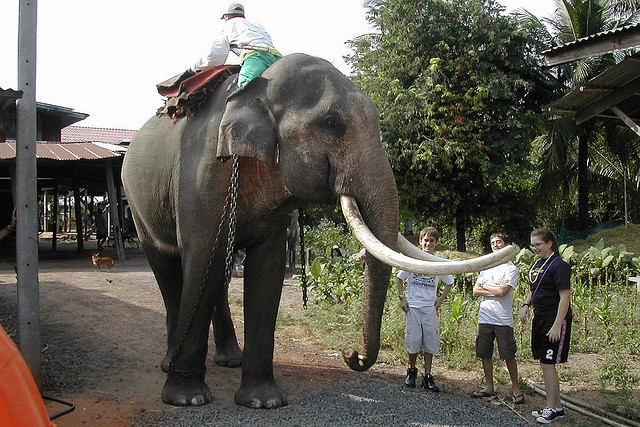Describe the objects in this image and their specific colors. I can see elephant in white, black, gray, and darkgray tones, people in white, black, gray, and darkgray tones, people in white, black, darkgray, and gray tones, people in white, darkgray, gray, and black tones, and people in white, darkgray, teal, and lightblue tones in this image. 